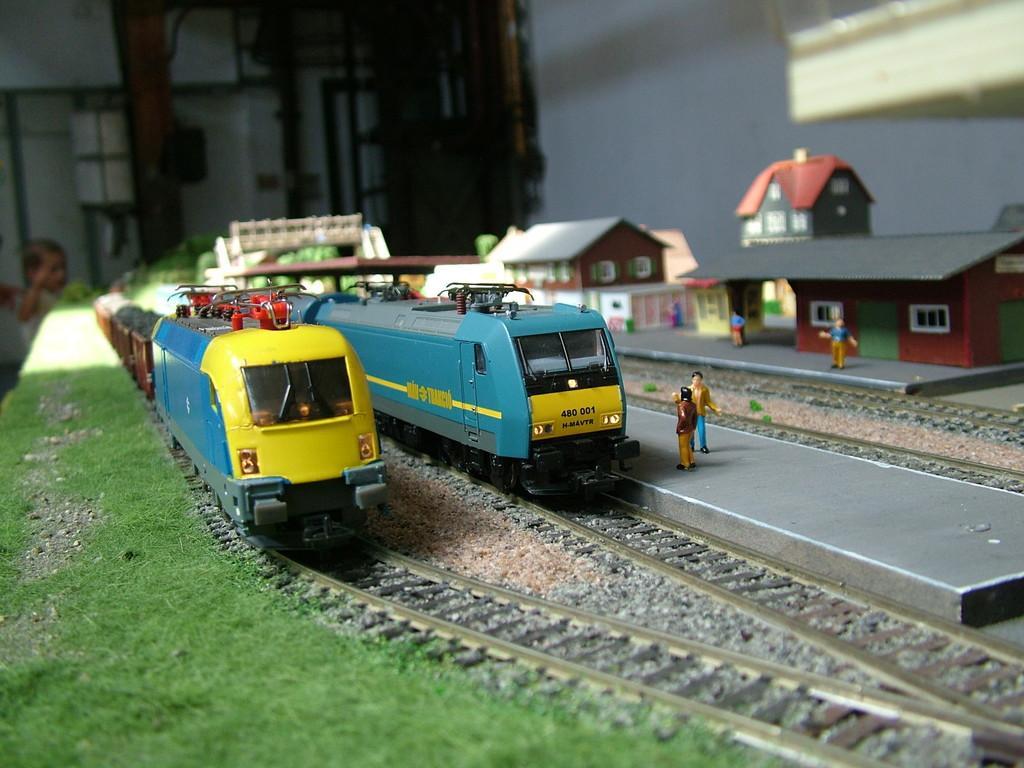Can you describe this image briefly? This is the picture of some toys which are in the shape of train on the track, horses, people and some grass. 